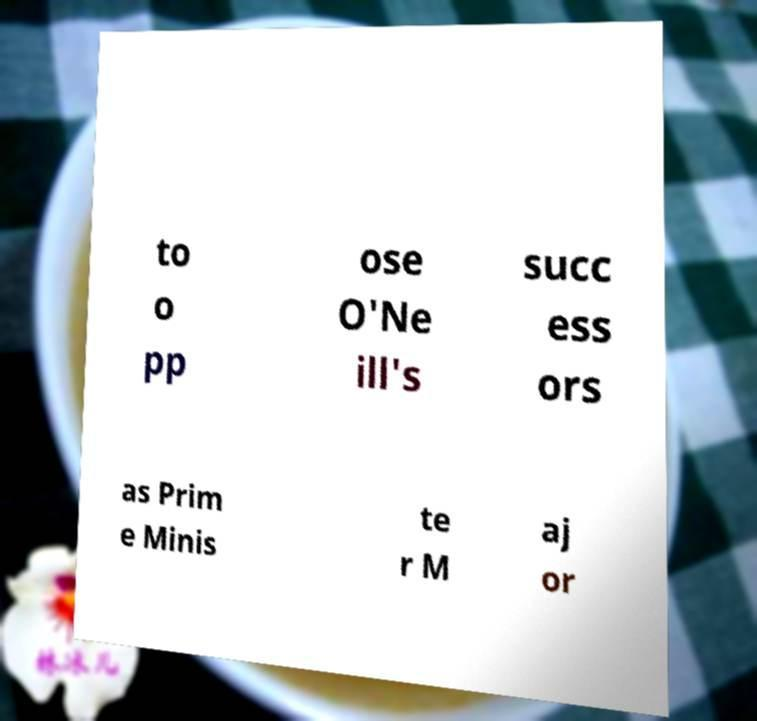Can you accurately transcribe the text from the provided image for me? to o pp ose O'Ne ill's succ ess ors as Prim e Minis te r M aj or 